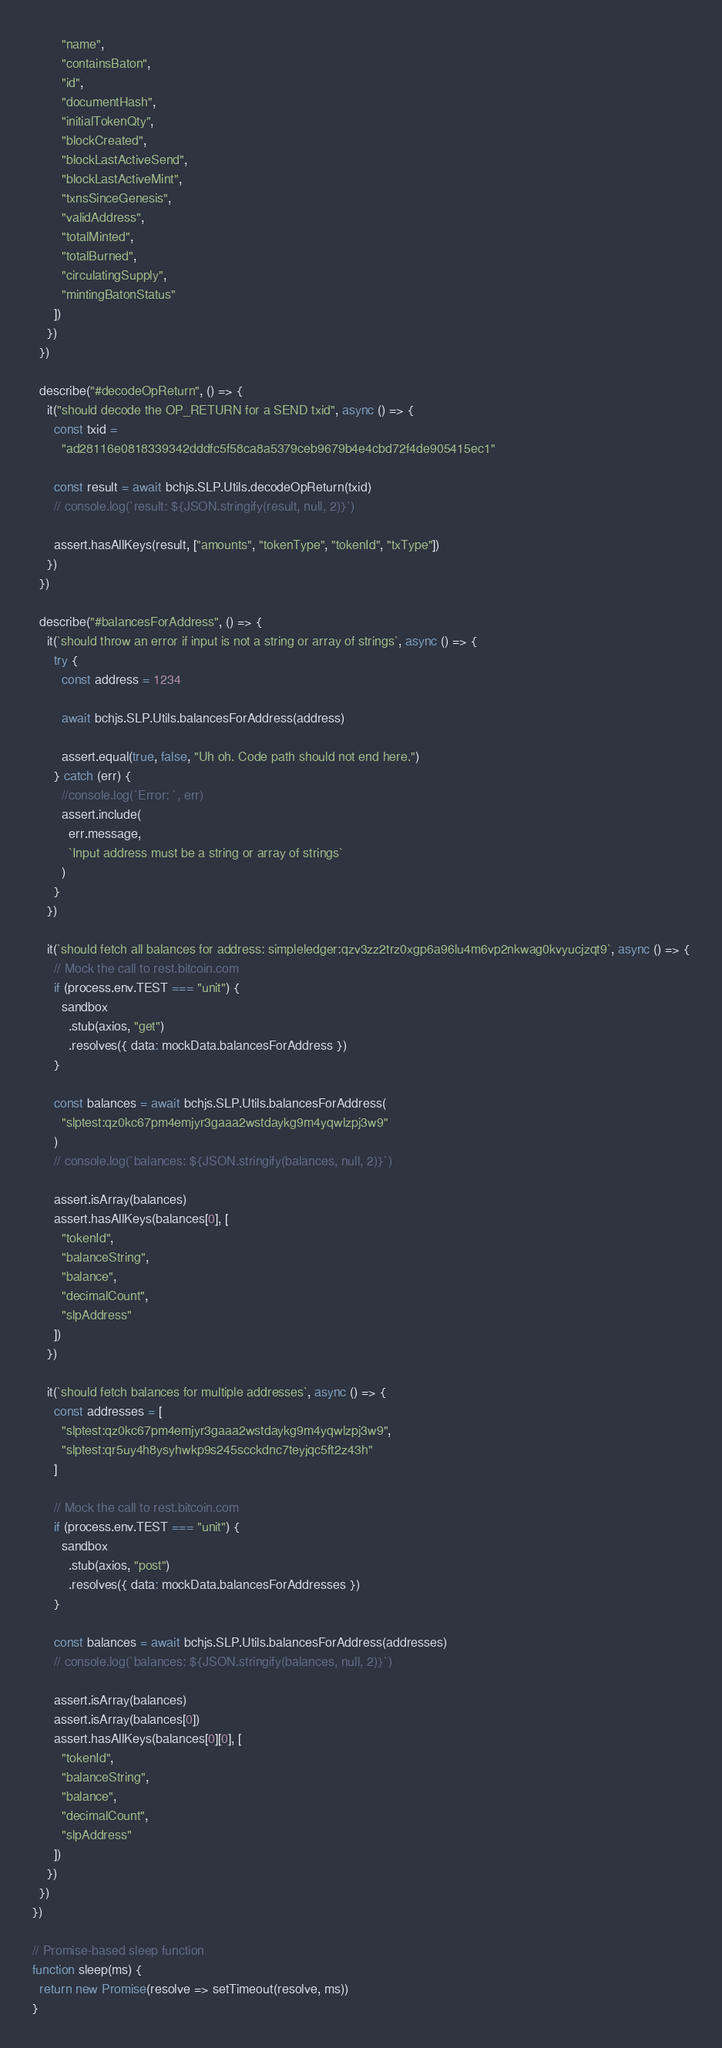<code> <loc_0><loc_0><loc_500><loc_500><_JavaScript_>        "name",
        "containsBaton",
        "id",
        "documentHash",
        "initialTokenQty",
        "blockCreated",
        "blockLastActiveSend",
        "blockLastActiveMint",
        "txnsSinceGenesis",
        "validAddress",
        "totalMinted",
        "totalBurned",
        "circulatingSupply",
        "mintingBatonStatus"
      ])
    })
  })

  describe("#decodeOpReturn", () => {
    it("should decode the OP_RETURN for a SEND txid", async () => {
      const txid =
        "ad28116e0818339342dddfc5f58ca8a5379ceb9679b4e4cbd72f4de905415ec1"

      const result = await bchjs.SLP.Utils.decodeOpReturn(txid)
      // console.log(`result: ${JSON.stringify(result, null, 2)}`)

      assert.hasAllKeys(result, ["amounts", "tokenType", "tokenId", "txType"])
    })
  })

  describe("#balancesForAddress", () => {
    it(`should throw an error if input is not a string or array of strings`, async () => {
      try {
        const address = 1234

        await bchjs.SLP.Utils.balancesForAddress(address)

        assert.equal(true, false, "Uh oh. Code path should not end here.")
      } catch (err) {
        //console.log(`Error: `, err)
        assert.include(
          err.message,
          `Input address must be a string or array of strings`
        )
      }
    })

    it(`should fetch all balances for address: simpleledger:qzv3zz2trz0xgp6a96lu4m6vp2nkwag0kvyucjzqt9`, async () => {
      // Mock the call to rest.bitcoin.com
      if (process.env.TEST === "unit") {
        sandbox
          .stub(axios, "get")
          .resolves({ data: mockData.balancesForAddress })
      }

      const balances = await bchjs.SLP.Utils.balancesForAddress(
        "slptest:qz0kc67pm4emjyr3gaaa2wstdaykg9m4yqwlzpj3w9"
      )
      // console.log(`balances: ${JSON.stringify(balances, null, 2)}`)

      assert.isArray(balances)
      assert.hasAllKeys(balances[0], [
        "tokenId",
        "balanceString",
        "balance",
        "decimalCount",
        "slpAddress"
      ])
    })

    it(`should fetch balances for multiple addresses`, async () => {
      const addresses = [
        "slptest:qz0kc67pm4emjyr3gaaa2wstdaykg9m4yqwlzpj3w9",
        "slptest:qr5uy4h8ysyhwkp9s245scckdnc7teyjqc5ft2z43h"
      ]

      // Mock the call to rest.bitcoin.com
      if (process.env.TEST === "unit") {
        sandbox
          .stub(axios, "post")
          .resolves({ data: mockData.balancesForAddresses })
      }

      const balances = await bchjs.SLP.Utils.balancesForAddress(addresses)
      // console.log(`balances: ${JSON.stringify(balances, null, 2)}`)

      assert.isArray(balances)
      assert.isArray(balances[0])
      assert.hasAllKeys(balances[0][0], [
        "tokenId",
        "balanceString",
        "balance",
        "decimalCount",
        "slpAddress"
      ])
    })
  })
})

// Promise-based sleep function
function sleep(ms) {
  return new Promise(resolve => setTimeout(resolve, ms))
}
</code> 